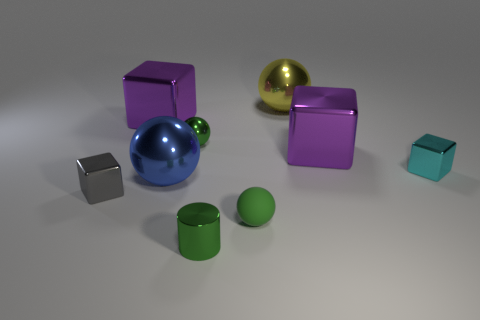How many cubes are either big things or large purple shiny things?
Provide a succinct answer. 2. There is a tiny object that is on the left side of the big object that is in front of the small cyan metal object; what is its color?
Offer a very short reply. Gray. What is the size of the rubber ball that is the same color as the cylinder?
Keep it short and to the point. Small. There is a large blue metallic object behind the small metallic cube on the left side of the large yellow sphere; what number of small blocks are in front of it?
Your answer should be compact. 1. Do the green thing behind the tiny gray metallic cube and the green rubber thing that is to the left of the big yellow metallic ball have the same shape?
Provide a succinct answer. Yes. What number of things are large purple spheres or big yellow metallic balls?
Ensure brevity in your answer.  1. What is the material of the cyan object on the right side of the green ball behind the tiny gray metallic object?
Provide a succinct answer. Metal. Is there a small ball that has the same color as the tiny matte thing?
Keep it short and to the point. Yes. What color is the metal sphere that is the same size as the yellow thing?
Ensure brevity in your answer.  Blue. What material is the small object that is to the right of the large object that is behind the large purple metallic cube left of the big blue metallic object?
Offer a terse response. Metal. 